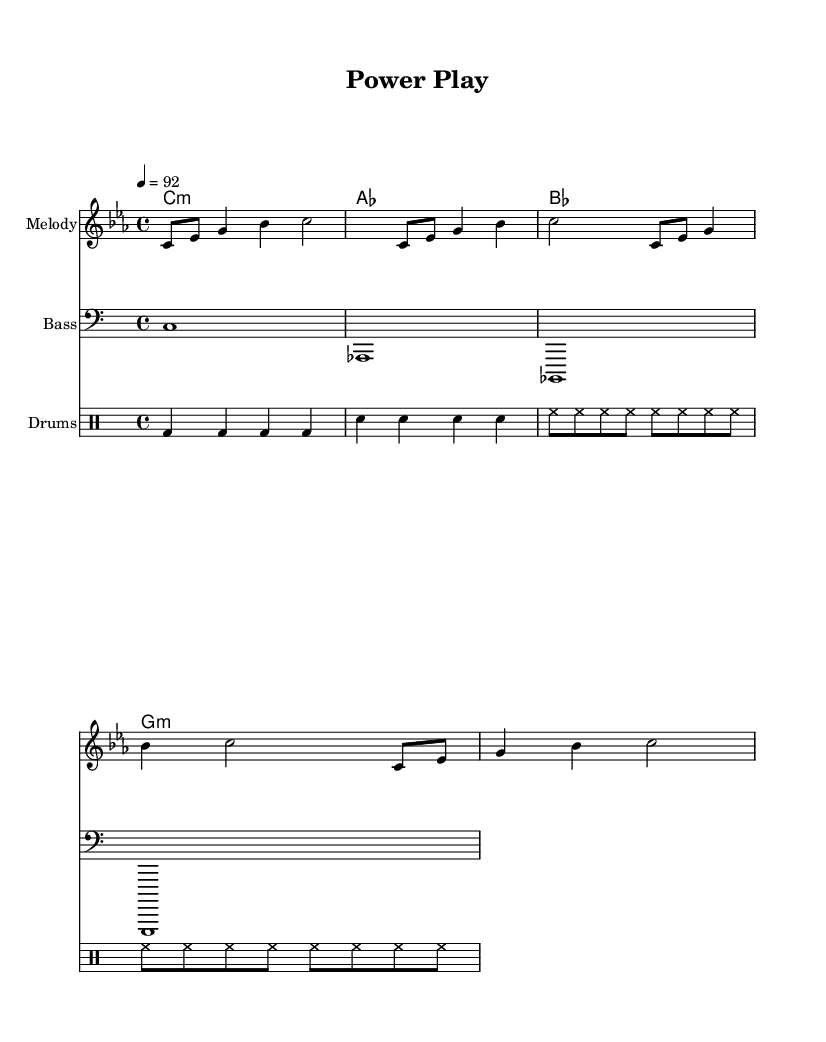What is the key signature of this music? The key signature is C minor, which is represented by three flats in the signature area of the staff.
Answer: C minor What is the time signature of this music? The time signature is indicated at the beginning of the sheet, showing that there are four beats per measure.
Answer: 4/4 What is the tempo of this piece? The tempo marking states the speed of the piece is a quarter note equals 92 beats per minute, notated at the beginning of the score.
Answer: 92 How many measures are in the melody section? The melody section consists of four lines, each containing one measure, totaling four measures.
Answer: 4 What is the bass clef used for in this piece? The bass clef is used in this piece to provide the lower harmonic foundation, indicating pitches that are lower than the treble registered in the melody staff.
Answer: Bass Which chord is played at the beginning of the score? The first chord shown is C minor, which is labeled at the beginning of the chord names section of the score.
Answer: C:m What type of percussion is featured in this score? The drumming section has a specific notation indicating the use of kick drum, snare, and hi-hat, which are all typical components of rap percussion.
Answer: Drum 